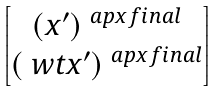Convert formula to latex. <formula><loc_0><loc_0><loc_500><loc_500>\begin{bmatrix} ( x ^ { \prime } ) ^ { \ a p x f i n a l } \\ ( \ w t x ^ { \prime } ) ^ { \ a p x f i n a l } \end{bmatrix}</formula> 